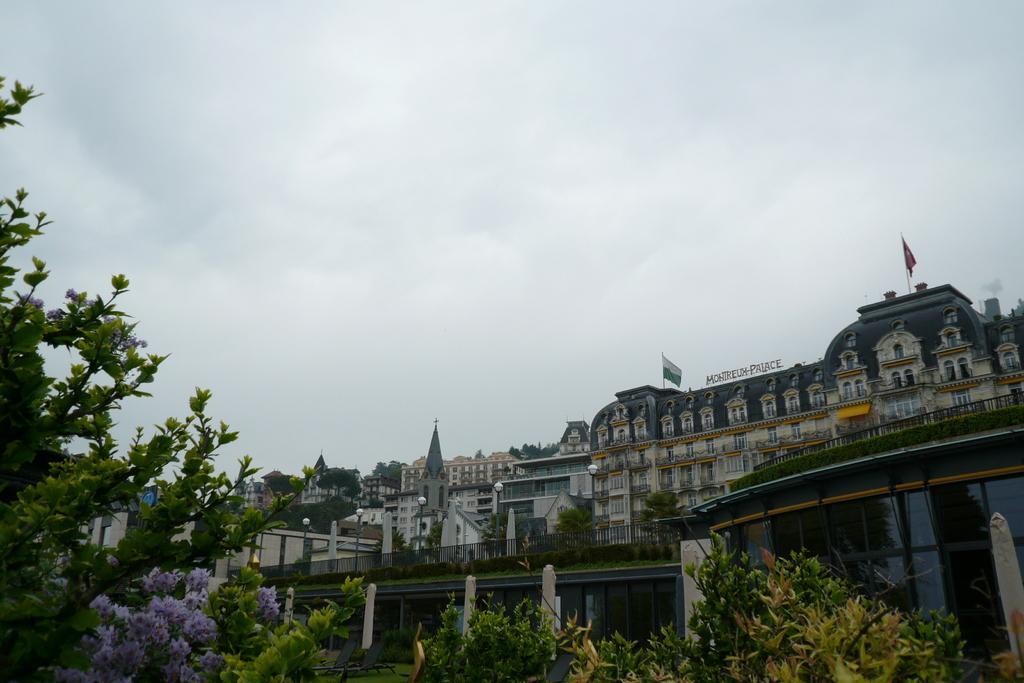Describe this image in one or two sentences. In this picture we can see trees and buildings and to the buildings there are poles with flags. Behind the building there is a cloudy sky. 